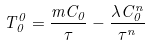Convert formula to latex. <formula><loc_0><loc_0><loc_500><loc_500>T _ { 0 } ^ { 0 } = \frac { m C _ { 0 } } { \tau } - \frac { \lambda C _ { 0 } ^ { n } } { \tau ^ { n } }</formula> 